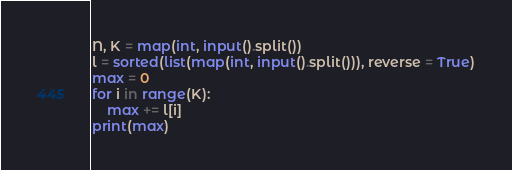Convert code to text. <code><loc_0><loc_0><loc_500><loc_500><_Python_>N, K = map(int, input().split())
l = sorted(list(map(int, input().split())), reverse = True)
max = 0
for i in range(K):
    max += l[i]
print(max)
</code> 